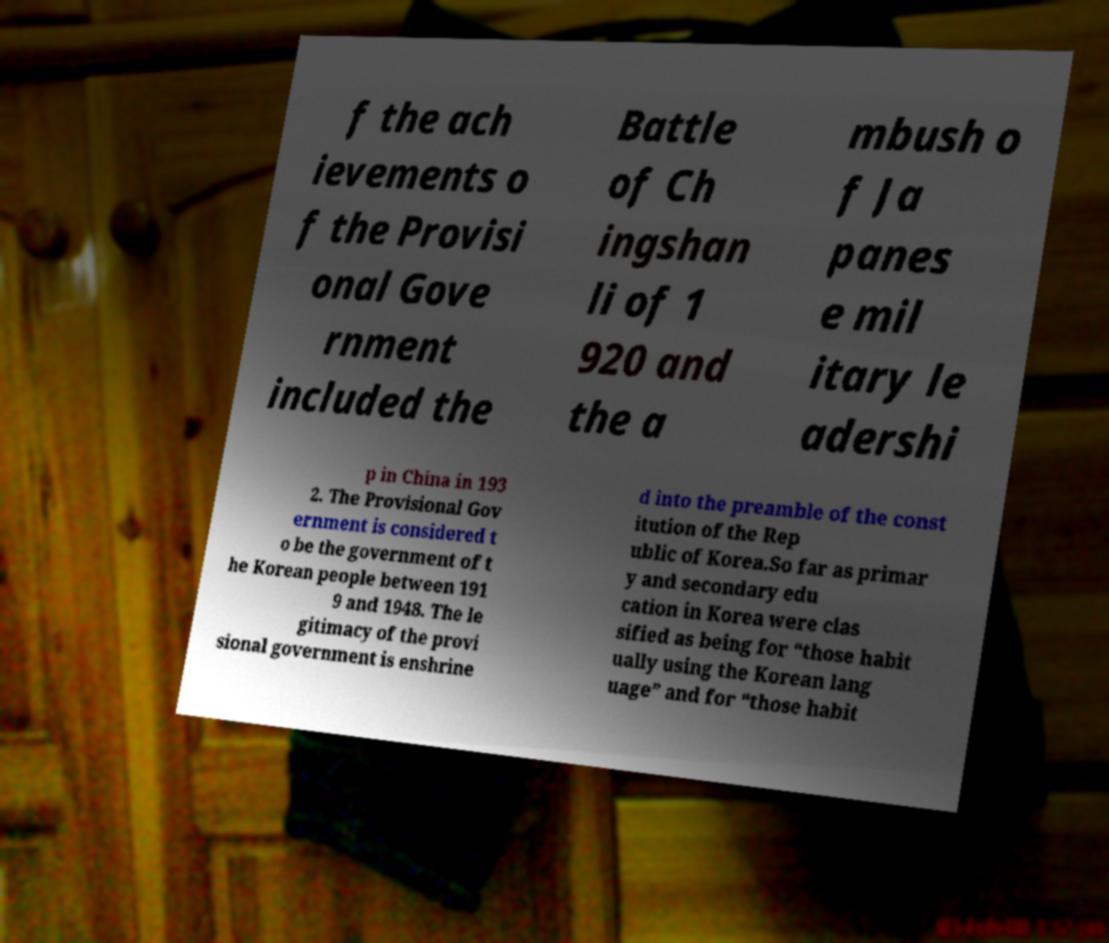For documentation purposes, I need the text within this image transcribed. Could you provide that? f the ach ievements o f the Provisi onal Gove rnment included the Battle of Ch ingshan li of 1 920 and the a mbush o f Ja panes e mil itary le adershi p in China in 193 2. The Provisional Gov ernment is considered t o be the government of t he Korean people between 191 9 and 1948. The le gitimacy of the provi sional government is enshrine d into the preamble of the const itution of the Rep ublic of Korea.So far as primar y and secondary edu cation in Korea were clas sified as being for “those habit ually using the Korean lang uage” and for “those habit 